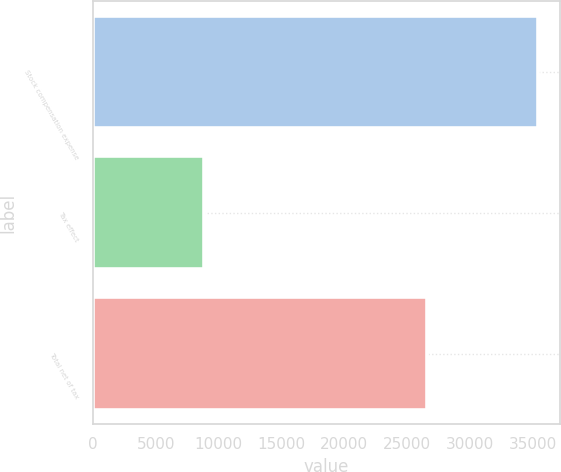Convert chart. <chart><loc_0><loc_0><loc_500><loc_500><bar_chart><fcel>Stock compensation expense<fcel>Tax effect<fcel>Total net of tax<nl><fcel>35409<fcel>8825<fcel>26584<nl></chart> 